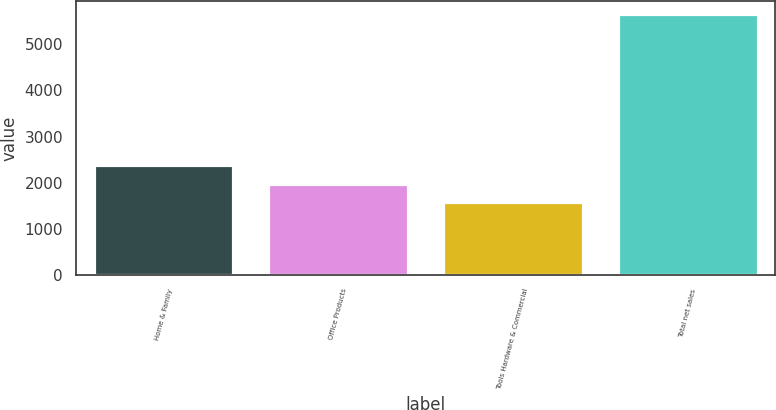Convert chart. <chart><loc_0><loc_0><loc_500><loc_500><bar_chart><fcel>Home & Family<fcel>Office Products<fcel>Tools Hardware & Commercial<fcel>Total net sales<nl><fcel>2388.36<fcel>1979.63<fcel>1570.9<fcel>5658.2<nl></chart> 